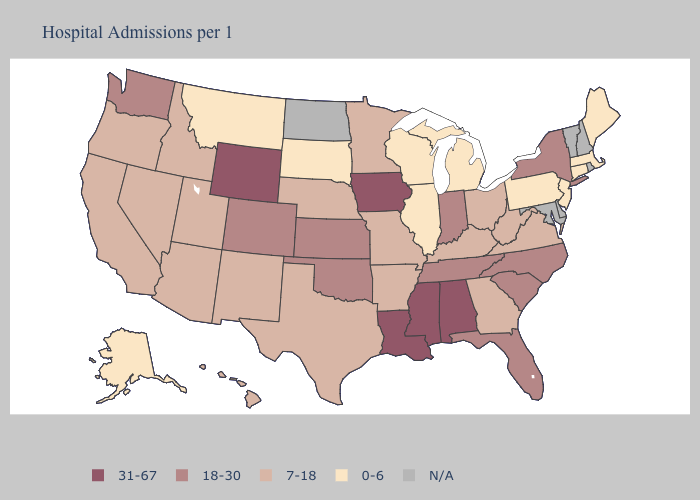Which states have the highest value in the USA?
Keep it brief. Alabama, Iowa, Louisiana, Mississippi, Wyoming. Does New Jersey have the highest value in the Northeast?
Short answer required. No. What is the highest value in the USA?
Be succinct. 31-67. What is the lowest value in the West?
Give a very brief answer. 0-6. Name the states that have a value in the range 7-18?
Keep it brief. Arizona, Arkansas, California, Georgia, Hawaii, Idaho, Kentucky, Minnesota, Missouri, Nebraska, Nevada, New Mexico, Ohio, Oregon, Texas, Utah, Virginia, West Virginia. Name the states that have a value in the range 0-6?
Keep it brief. Alaska, Connecticut, Illinois, Maine, Massachusetts, Michigan, Montana, New Jersey, Pennsylvania, South Dakota, Wisconsin. What is the highest value in states that border Massachusetts?
Keep it brief. 18-30. Does Utah have the highest value in the USA?
Answer briefly. No. Which states hav the highest value in the South?
Be succinct. Alabama, Louisiana, Mississippi. What is the highest value in the West ?
Be succinct. 31-67. Name the states that have a value in the range 0-6?
Keep it brief. Alaska, Connecticut, Illinois, Maine, Massachusetts, Michigan, Montana, New Jersey, Pennsylvania, South Dakota, Wisconsin. Which states have the highest value in the USA?
Concise answer only. Alabama, Iowa, Louisiana, Mississippi, Wyoming. Which states have the lowest value in the West?
Quick response, please. Alaska, Montana. 